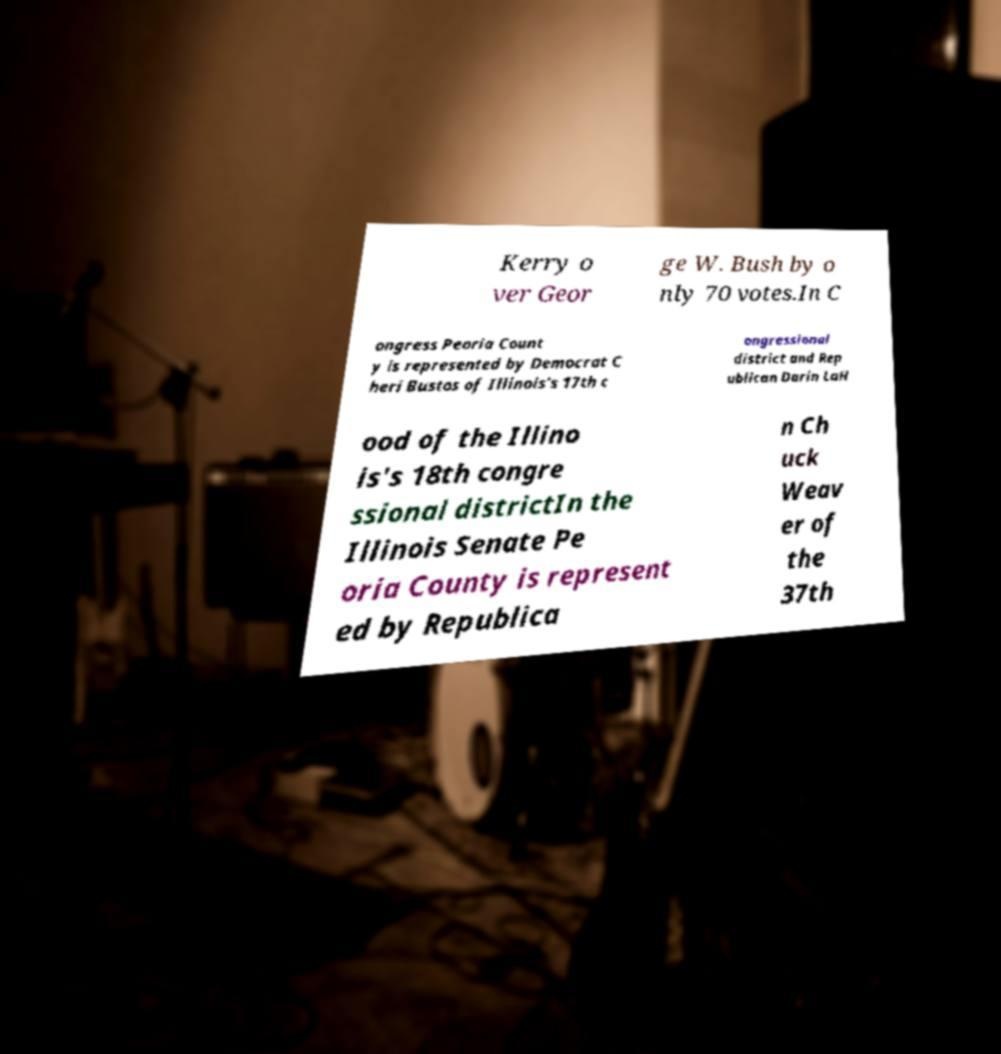Please identify and transcribe the text found in this image. Kerry o ver Geor ge W. Bush by o nly 70 votes.In C ongress Peoria Count y is represented by Democrat C heri Bustos of Illinois's 17th c ongressional district and Rep ublican Darin LaH ood of the Illino is's 18th congre ssional districtIn the Illinois Senate Pe oria County is represent ed by Republica n Ch uck Weav er of the 37th 